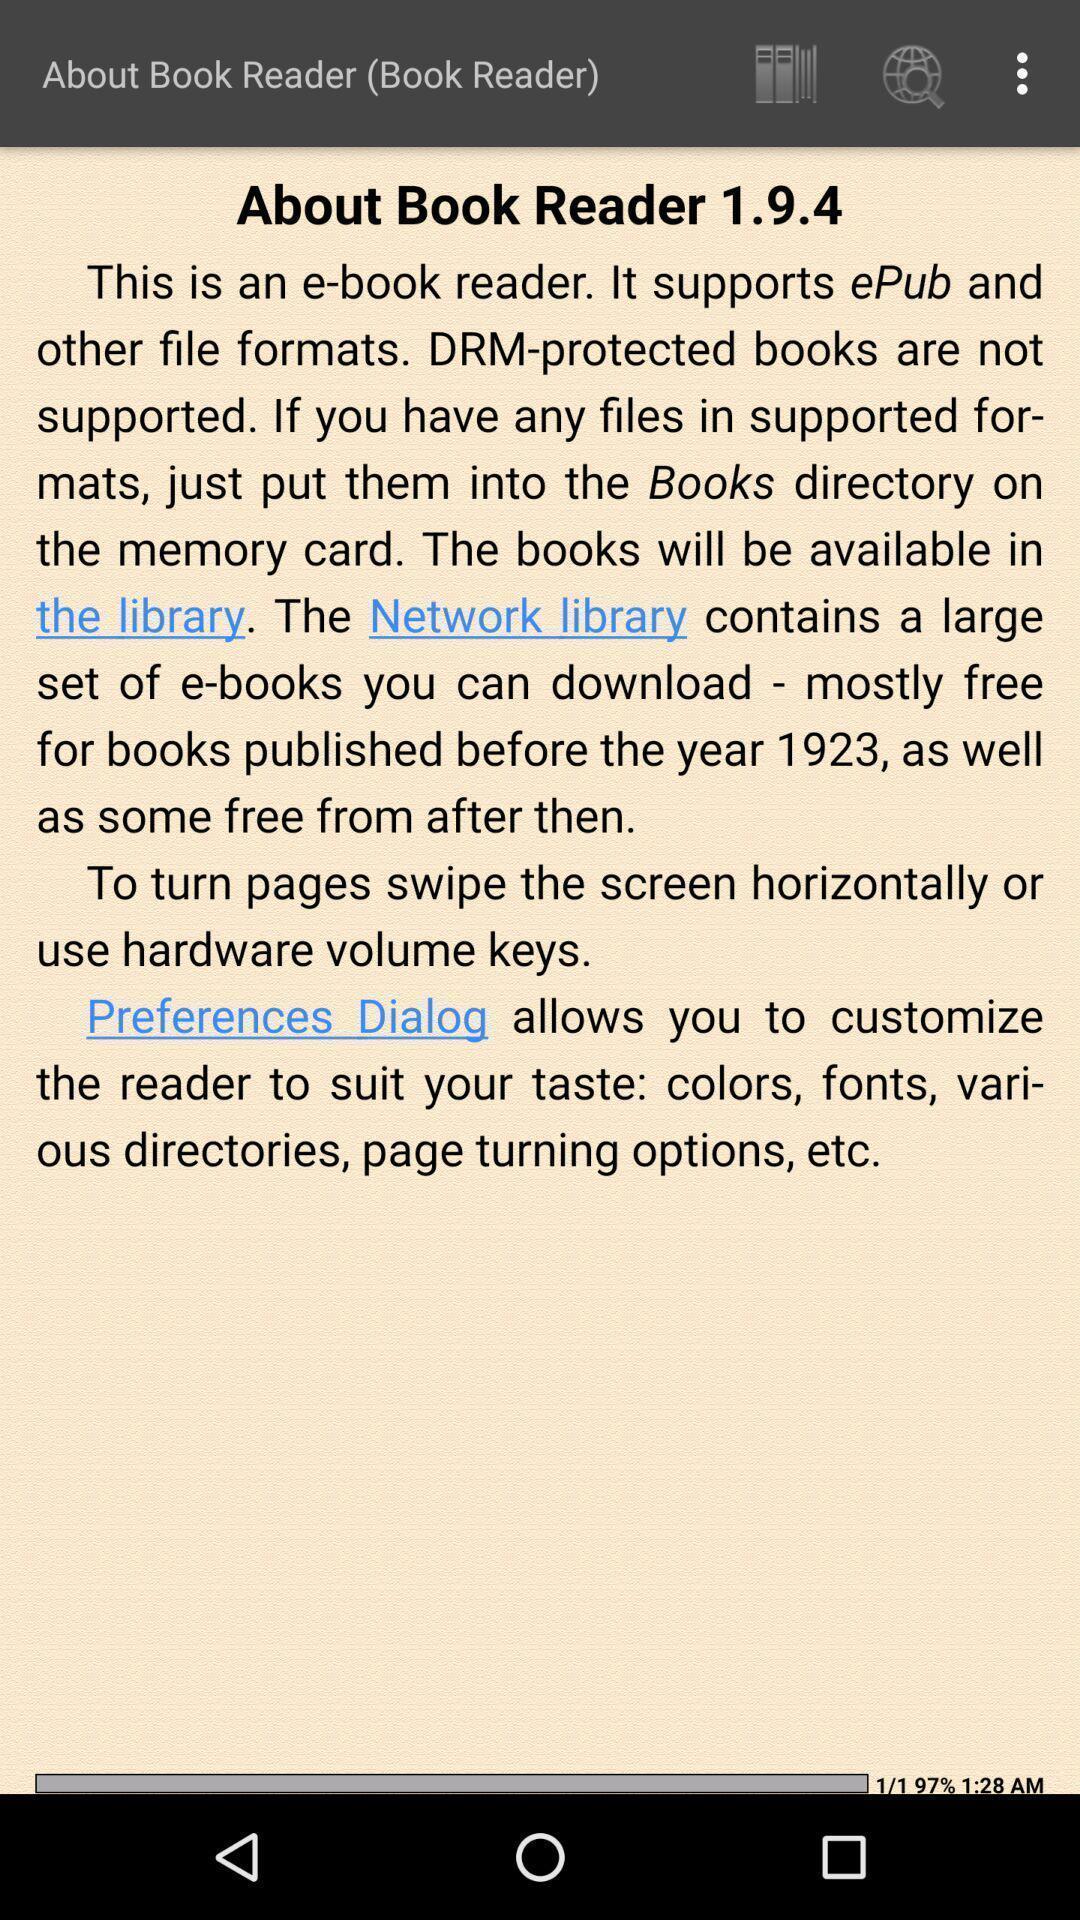Describe the key features of this screenshot. Screen displaying information about an application. 